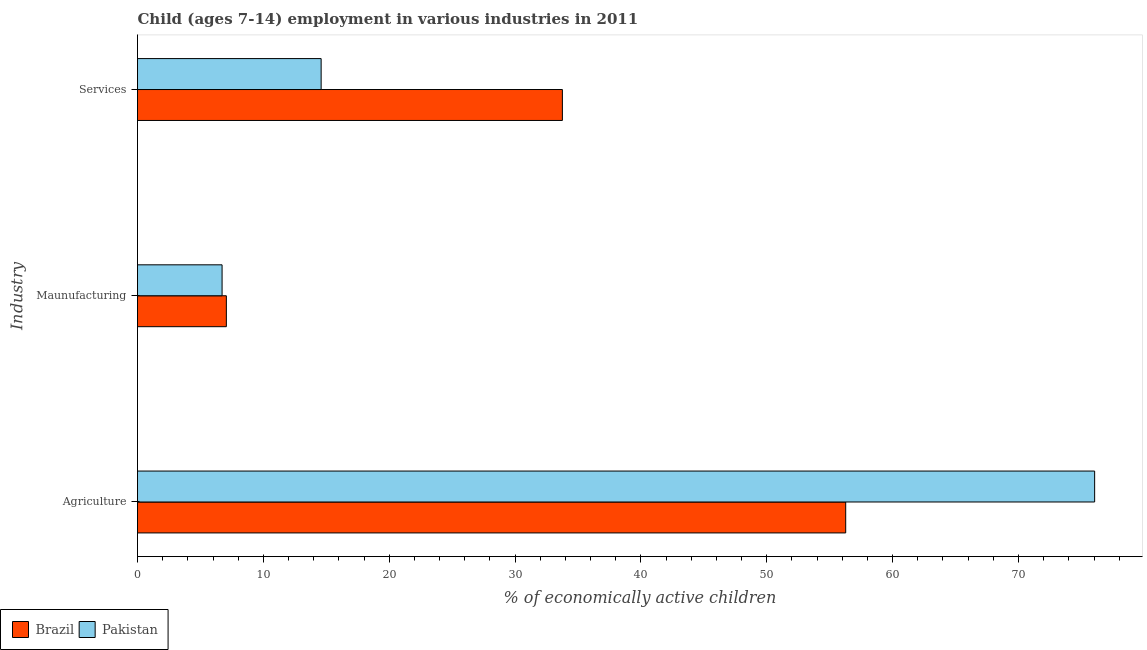How many different coloured bars are there?
Keep it short and to the point. 2. How many groups of bars are there?
Your response must be concise. 3. Are the number of bars per tick equal to the number of legend labels?
Make the answer very short. Yes. Are the number of bars on each tick of the Y-axis equal?
Your response must be concise. Yes. How many bars are there on the 2nd tick from the top?
Your response must be concise. 2. How many bars are there on the 3rd tick from the bottom?
Offer a terse response. 2. What is the label of the 3rd group of bars from the top?
Offer a terse response. Agriculture. What is the percentage of economically active children in services in Brazil?
Offer a very short reply. 33.76. Across all countries, what is the maximum percentage of economically active children in services?
Ensure brevity in your answer.  33.76. Across all countries, what is the minimum percentage of economically active children in agriculture?
Ensure brevity in your answer.  56.27. In which country was the percentage of economically active children in services minimum?
Offer a very short reply. Pakistan. What is the total percentage of economically active children in agriculture in the graph?
Provide a short and direct response. 132.32. What is the difference between the percentage of economically active children in agriculture in Brazil and that in Pakistan?
Offer a terse response. -19.78. What is the difference between the percentage of economically active children in services in Brazil and the percentage of economically active children in manufacturing in Pakistan?
Make the answer very short. 27.04. What is the average percentage of economically active children in services per country?
Your response must be concise. 24.17. What is the difference between the percentage of economically active children in agriculture and percentage of economically active children in services in Pakistan?
Your answer should be compact. 61.46. What is the ratio of the percentage of economically active children in agriculture in Brazil to that in Pakistan?
Keep it short and to the point. 0.74. Is the difference between the percentage of economically active children in manufacturing in Pakistan and Brazil greater than the difference between the percentage of economically active children in services in Pakistan and Brazil?
Your answer should be compact. Yes. What is the difference between the highest and the second highest percentage of economically active children in manufacturing?
Offer a very short reply. 0.34. What is the difference between the highest and the lowest percentage of economically active children in manufacturing?
Your answer should be very brief. 0.34. In how many countries, is the percentage of economically active children in services greater than the average percentage of economically active children in services taken over all countries?
Ensure brevity in your answer.  1. What does the 1st bar from the top in Agriculture represents?
Provide a short and direct response. Pakistan. What does the 2nd bar from the bottom in Agriculture represents?
Keep it short and to the point. Pakistan. How many bars are there?
Provide a short and direct response. 6. Are all the bars in the graph horizontal?
Provide a succinct answer. Yes. Does the graph contain any zero values?
Make the answer very short. No. How many legend labels are there?
Make the answer very short. 2. How are the legend labels stacked?
Offer a terse response. Horizontal. What is the title of the graph?
Ensure brevity in your answer.  Child (ages 7-14) employment in various industries in 2011. Does "Latin America(developing only)" appear as one of the legend labels in the graph?
Keep it short and to the point. No. What is the label or title of the X-axis?
Offer a very short reply. % of economically active children. What is the label or title of the Y-axis?
Give a very brief answer. Industry. What is the % of economically active children of Brazil in Agriculture?
Give a very brief answer. 56.27. What is the % of economically active children in Pakistan in Agriculture?
Provide a short and direct response. 76.05. What is the % of economically active children of Brazil in Maunufacturing?
Provide a succinct answer. 7.06. What is the % of economically active children in Pakistan in Maunufacturing?
Keep it short and to the point. 6.72. What is the % of economically active children of Brazil in Services?
Offer a very short reply. 33.76. What is the % of economically active children in Pakistan in Services?
Your answer should be very brief. 14.59. Across all Industry, what is the maximum % of economically active children in Brazil?
Offer a terse response. 56.27. Across all Industry, what is the maximum % of economically active children in Pakistan?
Provide a succinct answer. 76.05. Across all Industry, what is the minimum % of economically active children in Brazil?
Provide a succinct answer. 7.06. Across all Industry, what is the minimum % of economically active children of Pakistan?
Give a very brief answer. 6.72. What is the total % of economically active children in Brazil in the graph?
Your answer should be compact. 97.09. What is the total % of economically active children of Pakistan in the graph?
Offer a very short reply. 97.36. What is the difference between the % of economically active children in Brazil in Agriculture and that in Maunufacturing?
Keep it short and to the point. 49.21. What is the difference between the % of economically active children of Pakistan in Agriculture and that in Maunufacturing?
Offer a very short reply. 69.33. What is the difference between the % of economically active children in Brazil in Agriculture and that in Services?
Offer a terse response. 22.51. What is the difference between the % of economically active children in Pakistan in Agriculture and that in Services?
Your answer should be very brief. 61.46. What is the difference between the % of economically active children of Brazil in Maunufacturing and that in Services?
Your answer should be very brief. -26.7. What is the difference between the % of economically active children of Pakistan in Maunufacturing and that in Services?
Ensure brevity in your answer.  -7.87. What is the difference between the % of economically active children in Brazil in Agriculture and the % of economically active children in Pakistan in Maunufacturing?
Offer a very short reply. 49.55. What is the difference between the % of economically active children in Brazil in Agriculture and the % of economically active children in Pakistan in Services?
Make the answer very short. 41.68. What is the difference between the % of economically active children in Brazil in Maunufacturing and the % of economically active children in Pakistan in Services?
Your answer should be very brief. -7.53. What is the average % of economically active children in Brazil per Industry?
Offer a terse response. 32.36. What is the average % of economically active children in Pakistan per Industry?
Offer a terse response. 32.45. What is the difference between the % of economically active children of Brazil and % of economically active children of Pakistan in Agriculture?
Ensure brevity in your answer.  -19.78. What is the difference between the % of economically active children in Brazil and % of economically active children in Pakistan in Maunufacturing?
Keep it short and to the point. 0.34. What is the difference between the % of economically active children of Brazil and % of economically active children of Pakistan in Services?
Your answer should be compact. 19.17. What is the ratio of the % of economically active children of Brazil in Agriculture to that in Maunufacturing?
Provide a succinct answer. 7.97. What is the ratio of the % of economically active children in Pakistan in Agriculture to that in Maunufacturing?
Give a very brief answer. 11.32. What is the ratio of the % of economically active children of Brazil in Agriculture to that in Services?
Give a very brief answer. 1.67. What is the ratio of the % of economically active children in Pakistan in Agriculture to that in Services?
Make the answer very short. 5.21. What is the ratio of the % of economically active children of Brazil in Maunufacturing to that in Services?
Offer a very short reply. 0.21. What is the ratio of the % of economically active children in Pakistan in Maunufacturing to that in Services?
Provide a succinct answer. 0.46. What is the difference between the highest and the second highest % of economically active children of Brazil?
Keep it short and to the point. 22.51. What is the difference between the highest and the second highest % of economically active children in Pakistan?
Make the answer very short. 61.46. What is the difference between the highest and the lowest % of economically active children of Brazil?
Make the answer very short. 49.21. What is the difference between the highest and the lowest % of economically active children in Pakistan?
Provide a succinct answer. 69.33. 